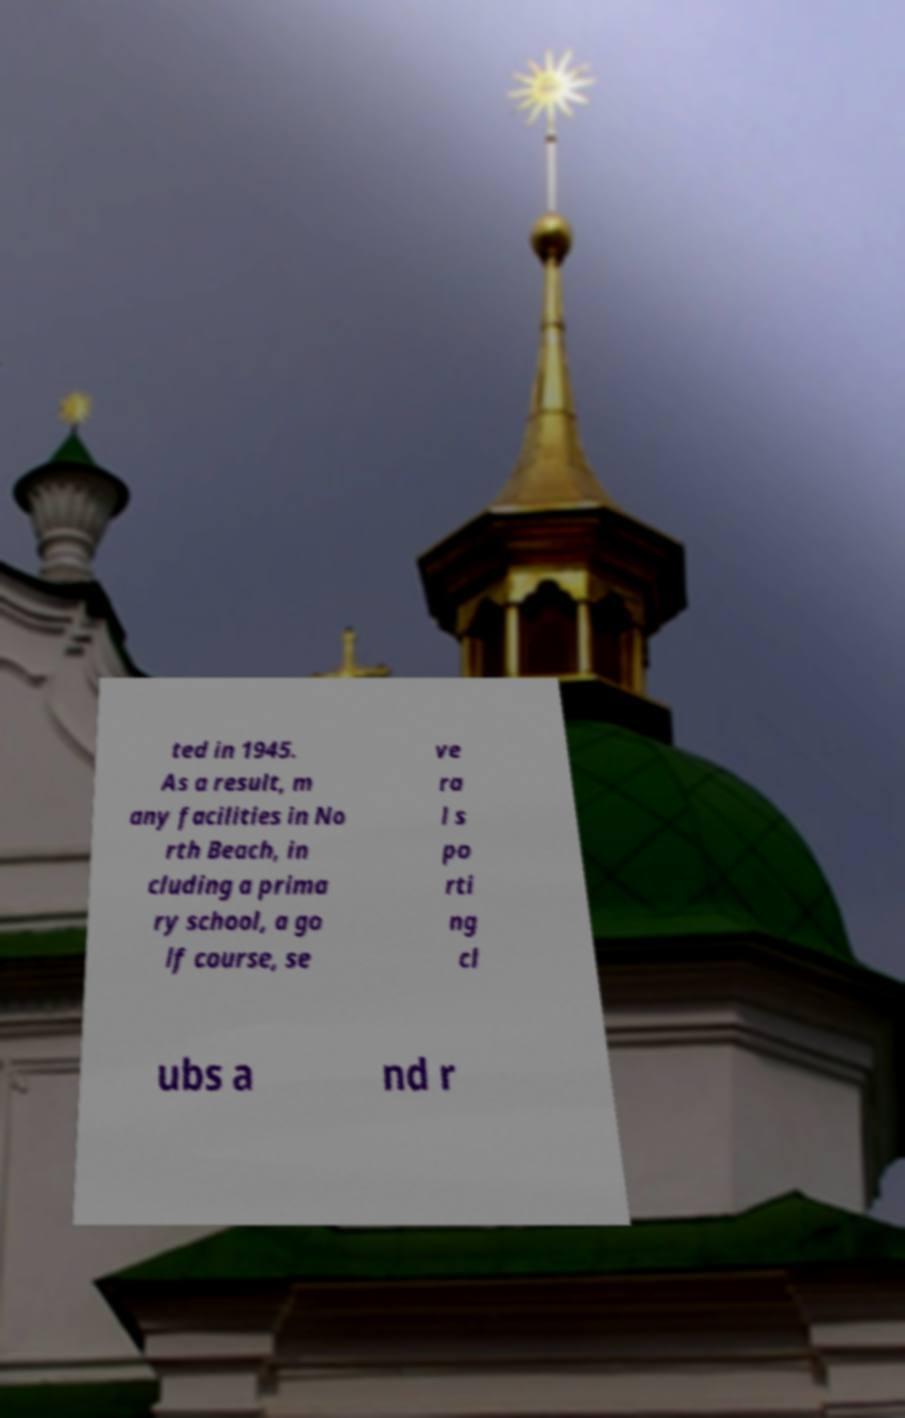Please read and relay the text visible in this image. What does it say? ted in 1945. As a result, m any facilities in No rth Beach, in cluding a prima ry school, a go lf course, se ve ra l s po rti ng cl ubs a nd r 